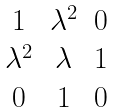<formula> <loc_0><loc_0><loc_500><loc_500>\begin{matrix} 1 & \lambda ^ { 2 } & 0 \\ \lambda ^ { 2 } & \lambda & 1 \\ 0 & 1 & 0 \end{matrix}</formula> 